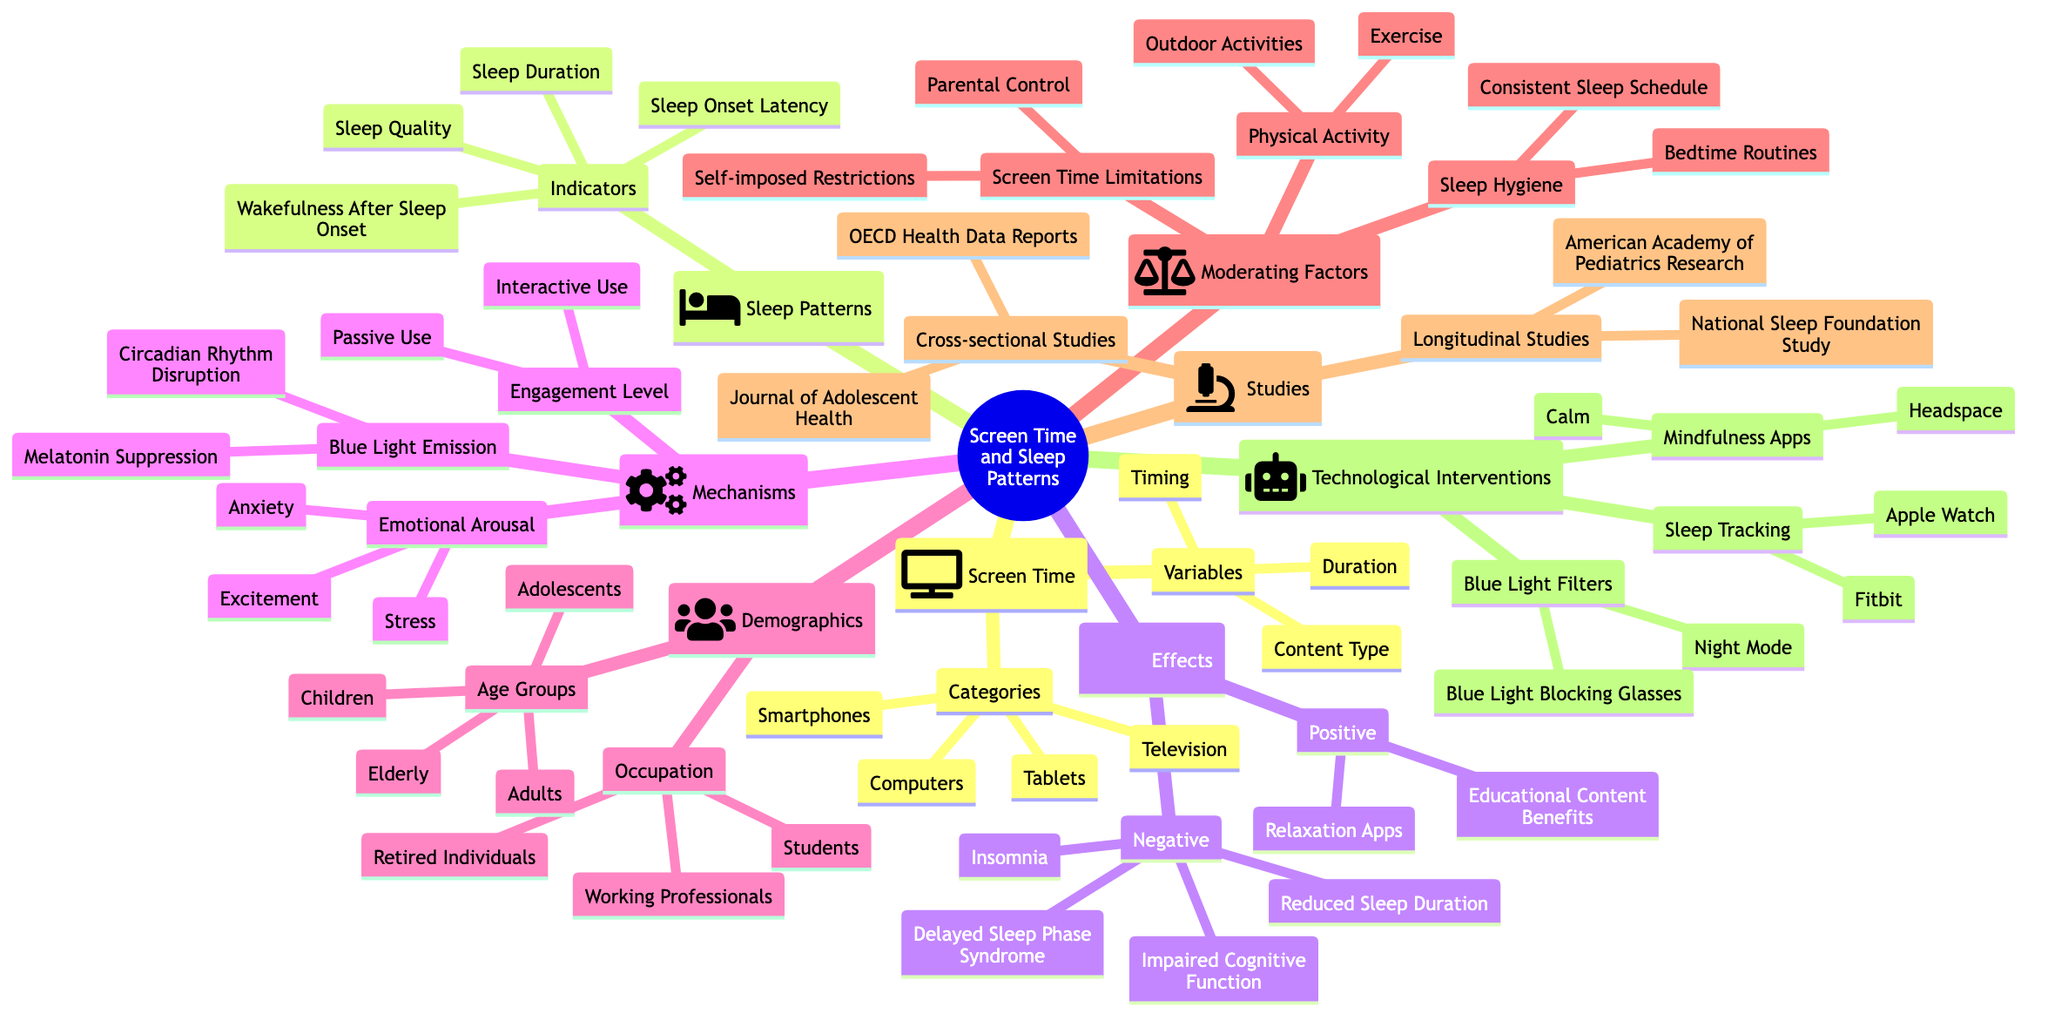What are the categories of screen time? The diagram lists four categories under screen time: Television, Smartphones, Tablets, and Computers. These are gathered directly under the "Categories" node within the "Screen Time" section.
Answer: Television, Smartphones, Tablets, Computers How many indicators are listed for sleep patterns? The "Sleep Patterns" section specifies four indicators: Sleep Duration, Sleep Quality, Sleep Onset Latency, and Wakefulness After Sleep Onset. By counting these, we find there are four indicators.
Answer: 4 Which negative effect is related to screen time? The "Negative" effects listed under "Effects" include Insomnia, Delayed Sleep Phase Syndrome, Reduced Sleep Duration, and Impaired Cognitive Function. The question asks for any one, so any mentioned would suffice; Insomnia can be picked here.
Answer: Insomnia What are two moderating factors influencing sleep patterns? Under the "Moderating Factors" section, there are categories like "Screen Time Limitations", "Sleep Hygiene", and "Physical Activity." Choosing any two from these categories, such as Screen Time Limitations and Sleep Hygiene, answers the question.
Answer: Screen Time Limitations, Sleep Hygiene Which age groups are affected by screen time? The diagram lists four age groups: Children, Adolescents, Adults, and Elderly under the "Demographics" section. These groups indicate the different ages that are considered in the context of screen time's effects on sleep.
Answer: Children, Adolescents, Adults, Elderly Which technological interventions are mentioned? The "Technological Interventions" section states three categories: Blue Light Filters, Mindfulness Apps, and Sleep Tracking. Each category contains specific examples, but any of these categories is acceptable.
Answer: Blue Light Filters, Mindfulness Apps, Sleep Tracking What is one mechanism related to emotional arousal? The diagram indicates emotional arousal includes Anxiety, Excitement, and Stress under the "Mechanisms" section specifically related to Emotional Arousal. Any one of these can be selected; choosing Anxiety works.
Answer: Anxiety Which study type encompasses the National Sleep Foundation Study? The National Sleep Foundation Study is categorized in "Longitudinal Studies" under the "Studies" section of the diagram. This clarifies the type of study associated with it.
Answer: Longitudinal Studies How does blue light emission affect sleep patterns? The diagram clarifies that blue light emission suppresses melatonin and disrupts circadian rhythms. These consequences signify how it negatively influences sleep patterns.
Answer: Melatonin Suppression, Circadian Rhythm Disruption 